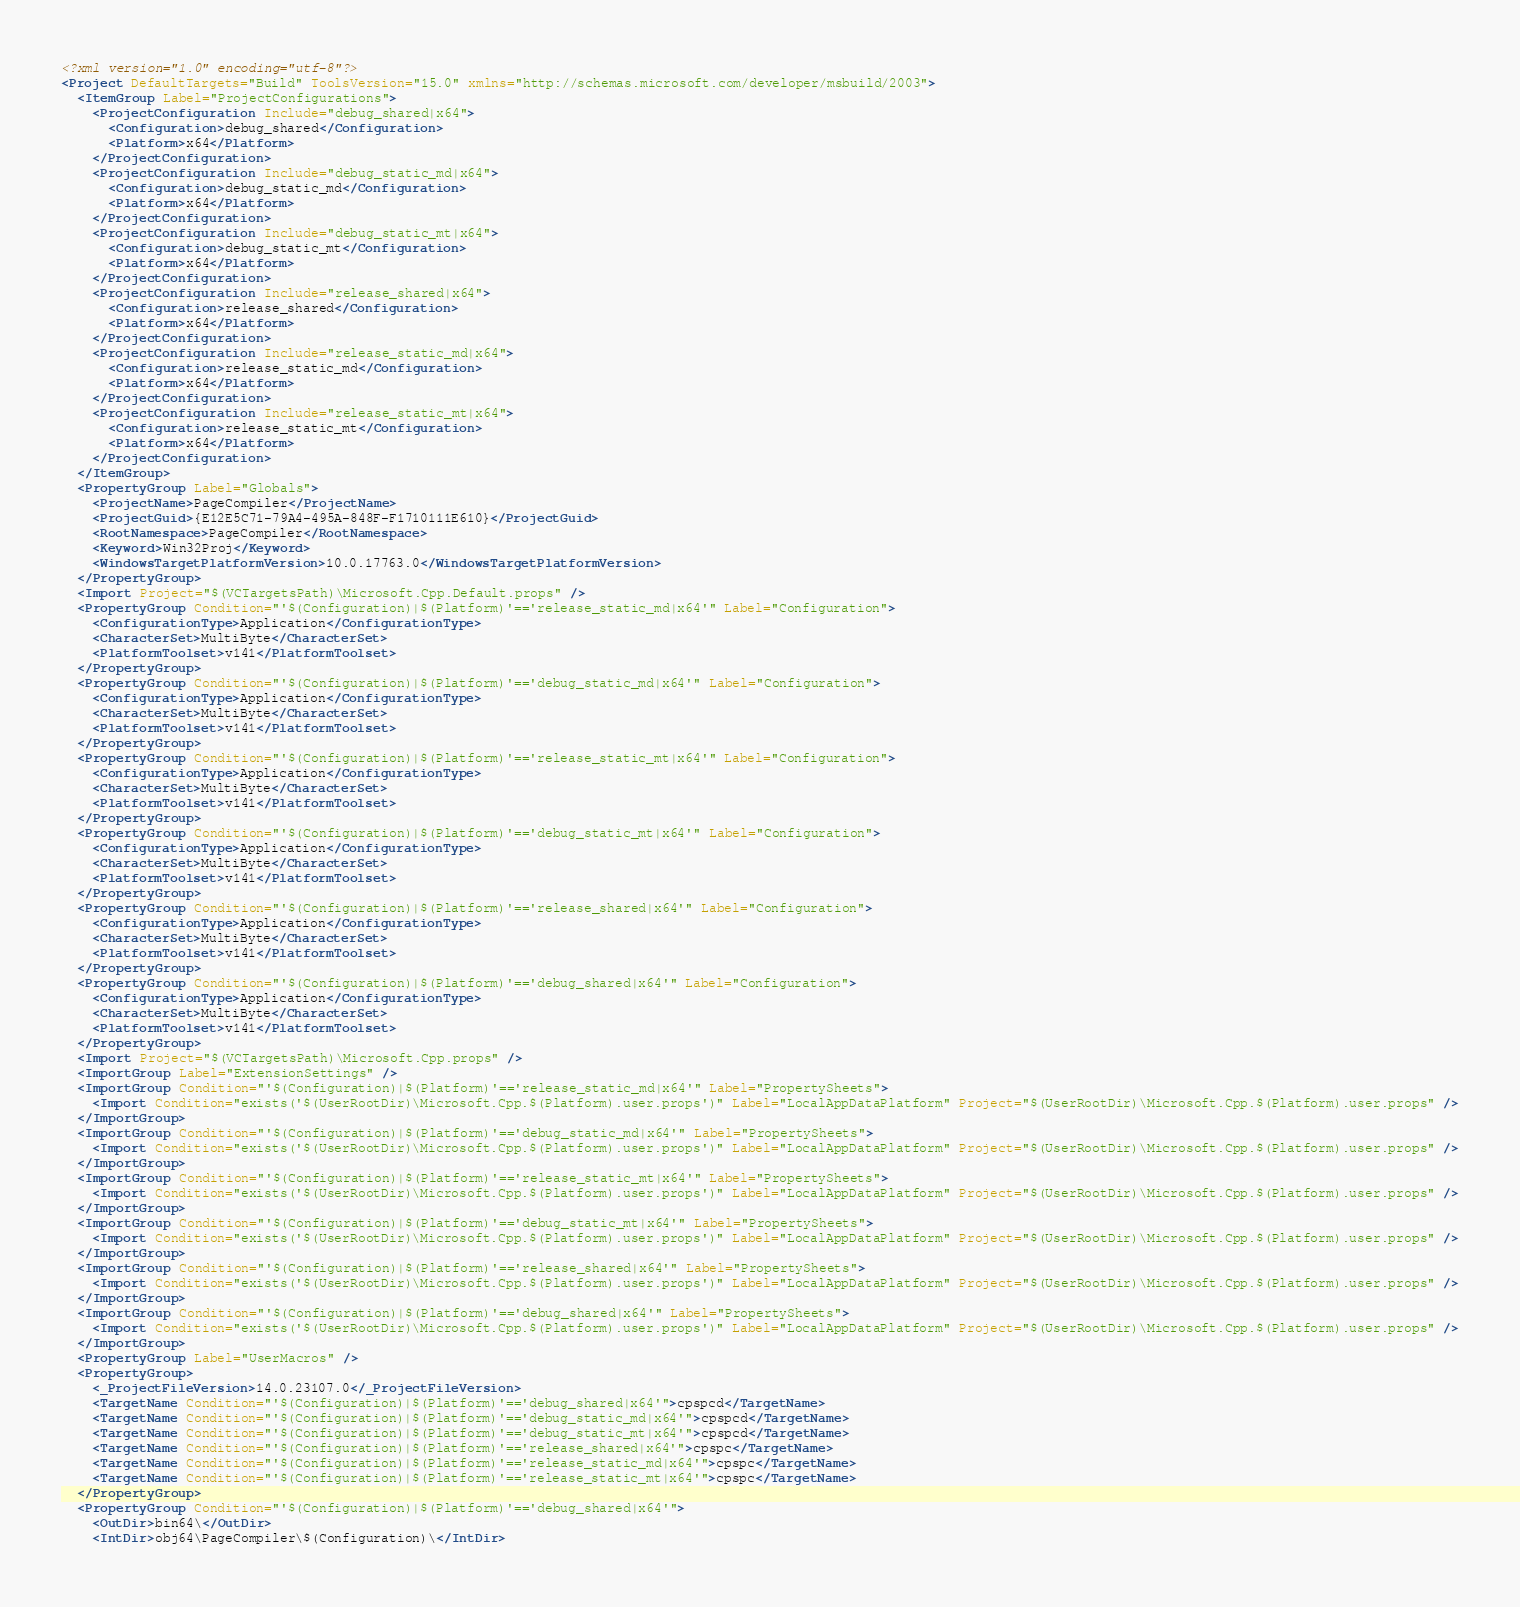Convert code to text. <code><loc_0><loc_0><loc_500><loc_500><_XML_><?xml version="1.0" encoding="utf-8"?>
<Project DefaultTargets="Build" ToolsVersion="15.0" xmlns="http://schemas.microsoft.com/developer/msbuild/2003">
  <ItemGroup Label="ProjectConfigurations">
    <ProjectConfiguration Include="debug_shared|x64">
      <Configuration>debug_shared</Configuration>
      <Platform>x64</Platform>
    </ProjectConfiguration>
    <ProjectConfiguration Include="debug_static_md|x64">
      <Configuration>debug_static_md</Configuration>
      <Platform>x64</Platform>
    </ProjectConfiguration>
    <ProjectConfiguration Include="debug_static_mt|x64">
      <Configuration>debug_static_mt</Configuration>
      <Platform>x64</Platform>
    </ProjectConfiguration>
    <ProjectConfiguration Include="release_shared|x64">
      <Configuration>release_shared</Configuration>
      <Platform>x64</Platform>
    </ProjectConfiguration>
    <ProjectConfiguration Include="release_static_md|x64">
      <Configuration>release_static_md</Configuration>
      <Platform>x64</Platform>
    </ProjectConfiguration>
    <ProjectConfiguration Include="release_static_mt|x64">
      <Configuration>release_static_mt</Configuration>
      <Platform>x64</Platform>
    </ProjectConfiguration>
  </ItemGroup>
  <PropertyGroup Label="Globals">
    <ProjectName>PageCompiler</ProjectName>
    <ProjectGuid>{E12E5C71-79A4-495A-848F-F1710111E610}</ProjectGuid>
    <RootNamespace>PageCompiler</RootNamespace>
    <Keyword>Win32Proj</Keyword>
    <WindowsTargetPlatformVersion>10.0.17763.0</WindowsTargetPlatformVersion>
  </PropertyGroup>
  <Import Project="$(VCTargetsPath)\Microsoft.Cpp.Default.props" />
  <PropertyGroup Condition="'$(Configuration)|$(Platform)'=='release_static_md|x64'" Label="Configuration">
    <ConfigurationType>Application</ConfigurationType>
    <CharacterSet>MultiByte</CharacterSet>
    <PlatformToolset>v141</PlatformToolset>
  </PropertyGroup>
  <PropertyGroup Condition="'$(Configuration)|$(Platform)'=='debug_static_md|x64'" Label="Configuration">
    <ConfigurationType>Application</ConfigurationType>
    <CharacterSet>MultiByte</CharacterSet>
    <PlatformToolset>v141</PlatformToolset>
  </PropertyGroup>
  <PropertyGroup Condition="'$(Configuration)|$(Platform)'=='release_static_mt|x64'" Label="Configuration">
    <ConfigurationType>Application</ConfigurationType>
    <CharacterSet>MultiByte</CharacterSet>
    <PlatformToolset>v141</PlatformToolset>
  </PropertyGroup>
  <PropertyGroup Condition="'$(Configuration)|$(Platform)'=='debug_static_mt|x64'" Label="Configuration">
    <ConfigurationType>Application</ConfigurationType>
    <CharacterSet>MultiByte</CharacterSet>
    <PlatformToolset>v141</PlatformToolset>
  </PropertyGroup>
  <PropertyGroup Condition="'$(Configuration)|$(Platform)'=='release_shared|x64'" Label="Configuration">
    <ConfigurationType>Application</ConfigurationType>
    <CharacterSet>MultiByte</CharacterSet>
    <PlatformToolset>v141</PlatformToolset>
  </PropertyGroup>
  <PropertyGroup Condition="'$(Configuration)|$(Platform)'=='debug_shared|x64'" Label="Configuration">
    <ConfigurationType>Application</ConfigurationType>
    <CharacterSet>MultiByte</CharacterSet>
    <PlatformToolset>v141</PlatformToolset>
  </PropertyGroup>
  <Import Project="$(VCTargetsPath)\Microsoft.Cpp.props" />
  <ImportGroup Label="ExtensionSettings" />
  <ImportGroup Condition="'$(Configuration)|$(Platform)'=='release_static_md|x64'" Label="PropertySheets">
    <Import Condition="exists('$(UserRootDir)\Microsoft.Cpp.$(Platform).user.props')" Label="LocalAppDataPlatform" Project="$(UserRootDir)\Microsoft.Cpp.$(Platform).user.props" />
  </ImportGroup>
  <ImportGroup Condition="'$(Configuration)|$(Platform)'=='debug_static_md|x64'" Label="PropertySheets">
    <Import Condition="exists('$(UserRootDir)\Microsoft.Cpp.$(Platform).user.props')" Label="LocalAppDataPlatform" Project="$(UserRootDir)\Microsoft.Cpp.$(Platform).user.props" />
  </ImportGroup>
  <ImportGroup Condition="'$(Configuration)|$(Platform)'=='release_static_mt|x64'" Label="PropertySheets">
    <Import Condition="exists('$(UserRootDir)\Microsoft.Cpp.$(Platform).user.props')" Label="LocalAppDataPlatform" Project="$(UserRootDir)\Microsoft.Cpp.$(Platform).user.props" />
  </ImportGroup>
  <ImportGroup Condition="'$(Configuration)|$(Platform)'=='debug_static_mt|x64'" Label="PropertySheets">
    <Import Condition="exists('$(UserRootDir)\Microsoft.Cpp.$(Platform).user.props')" Label="LocalAppDataPlatform" Project="$(UserRootDir)\Microsoft.Cpp.$(Platform).user.props" />
  </ImportGroup>
  <ImportGroup Condition="'$(Configuration)|$(Platform)'=='release_shared|x64'" Label="PropertySheets">
    <Import Condition="exists('$(UserRootDir)\Microsoft.Cpp.$(Platform).user.props')" Label="LocalAppDataPlatform" Project="$(UserRootDir)\Microsoft.Cpp.$(Platform).user.props" />
  </ImportGroup>
  <ImportGroup Condition="'$(Configuration)|$(Platform)'=='debug_shared|x64'" Label="PropertySheets">
    <Import Condition="exists('$(UserRootDir)\Microsoft.Cpp.$(Platform).user.props')" Label="LocalAppDataPlatform" Project="$(UserRootDir)\Microsoft.Cpp.$(Platform).user.props" />
  </ImportGroup>
  <PropertyGroup Label="UserMacros" />
  <PropertyGroup>
    <_ProjectFileVersion>14.0.23107.0</_ProjectFileVersion>
    <TargetName Condition="'$(Configuration)|$(Platform)'=='debug_shared|x64'">cpspcd</TargetName>
    <TargetName Condition="'$(Configuration)|$(Platform)'=='debug_static_md|x64'">cpspcd</TargetName>
    <TargetName Condition="'$(Configuration)|$(Platform)'=='debug_static_mt|x64'">cpspcd</TargetName>
    <TargetName Condition="'$(Configuration)|$(Platform)'=='release_shared|x64'">cpspc</TargetName>
    <TargetName Condition="'$(Configuration)|$(Platform)'=='release_static_md|x64'">cpspc</TargetName>
    <TargetName Condition="'$(Configuration)|$(Platform)'=='release_static_mt|x64'">cpspc</TargetName>
  </PropertyGroup>
  <PropertyGroup Condition="'$(Configuration)|$(Platform)'=='debug_shared|x64'">
    <OutDir>bin64\</OutDir>
    <IntDir>obj64\PageCompiler\$(Configuration)\</IntDir></code> 